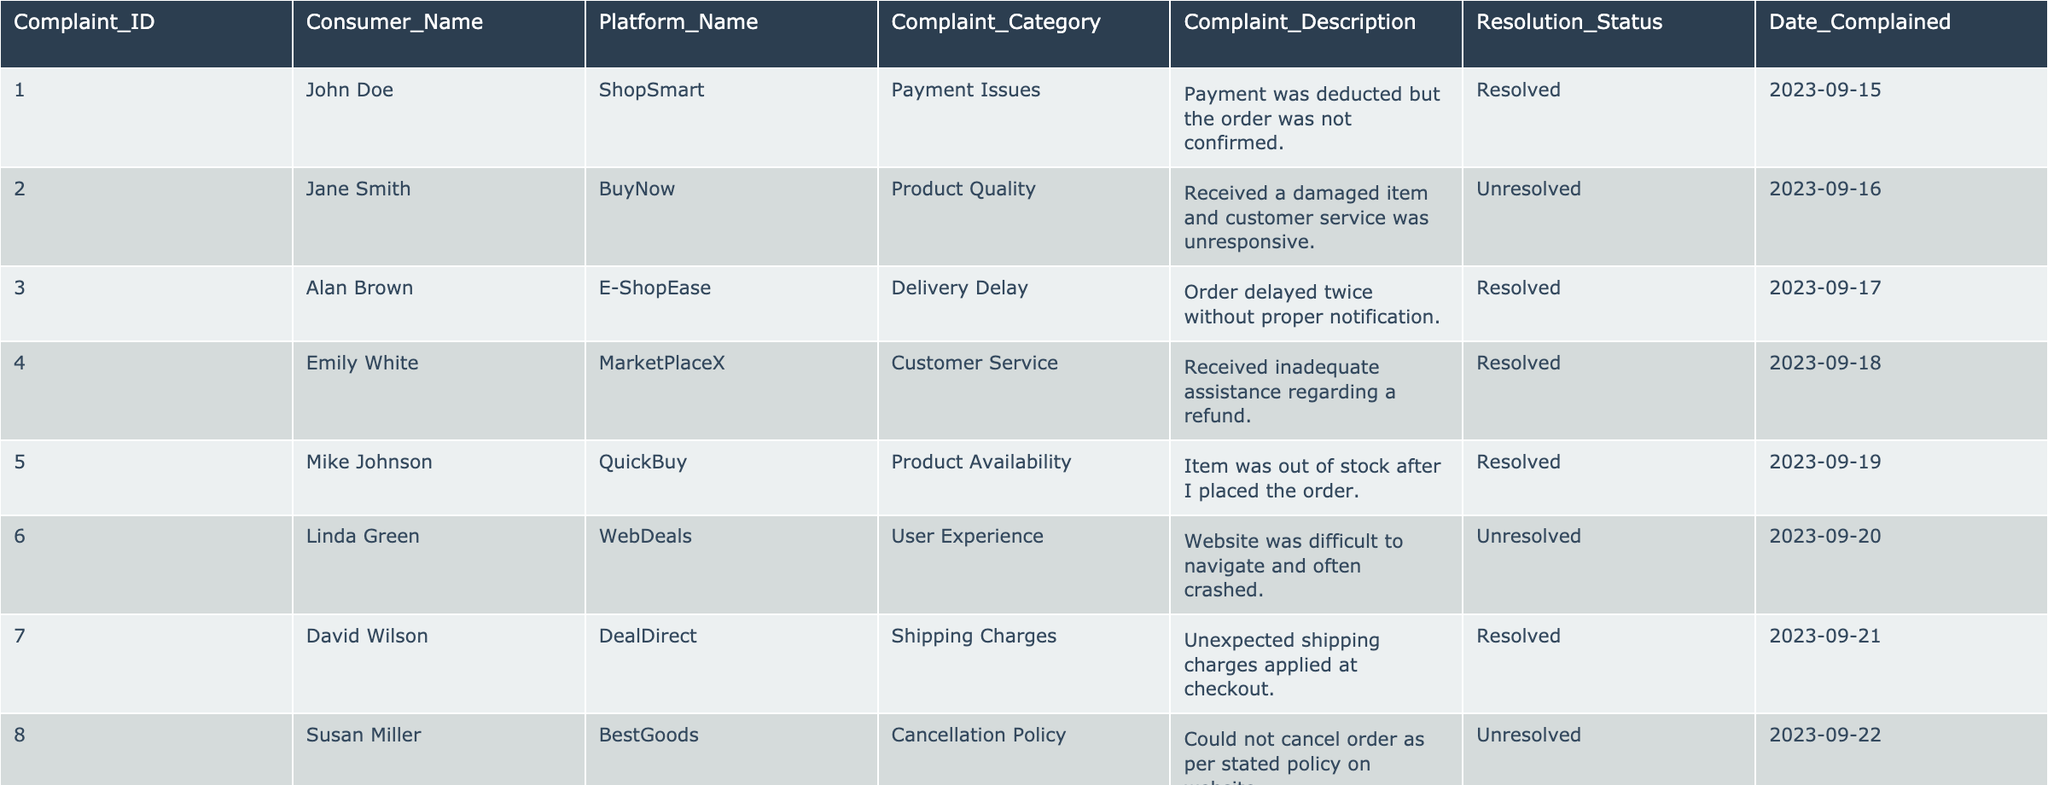What is the total number of complaints in the table? There are 10 rows in the table, each representing a separate complaint, so the total number of complaints is equal to the number of rows.
Answer: 10 How many complaints remain unresolved? By examining the 'Resolution_Status' column, 4 out of the 10 complaints are labeled as "Unresolved".
Answer: 4 Which platform has the highest number of complaints? Counting the occurrences of each platform in the 'Platform_Name' column, each platform has only one complaint, making it impossible to determine a single platform with the highest number.
Answer: None (all platforms have one complaint each) What is the average time taken for resolution of complaints based on the date complained? The complaints that are resolved were mentioned on 15th, 17th, 18th, 19th, 21st, and 23rd, yielding a total duration of days from the complaint to the resolution. To determine the average, we calculate the days individually and sum them up then divide by the number of resolved complaints (6).
Answer: 2.5 days Is there a complaint regarding user experience in the table? Yes, there is one complaint listed under the 'User Experience' category in the 'Complaint_Category' column.
Answer: Yes How many complaints were made about payment issues and what was their resolution status? There is 1 complaint regarding payment issues, which is labeled as "Resolved" in the 'Resolution_Status' column.
Answer: 1 complaint, Resolved Identify any instance where a consumer reported product misrepresentation. In the 'Complaint_Description' column, one complaint is noted for "Received a different product than was advertised," indicating a case of product misrepresentation.
Answer: Yes, 1 instance Which complaint category had the least number of complaints? Compared by counting, categories like 'Product Availability', 'Shipping Charges', and 'Payment Issues' each have one complaint, indicating that there are several categories with the least number.
Answer: Multiple categories (3 complaints) Are there any complaints where the consumer received no assistance at all? The table indicates that there is a complaint marked as "Unresolved" regarding customer service assistance in regard to a refund, suggesting a complete lack of assistance.
Answer: Yes 